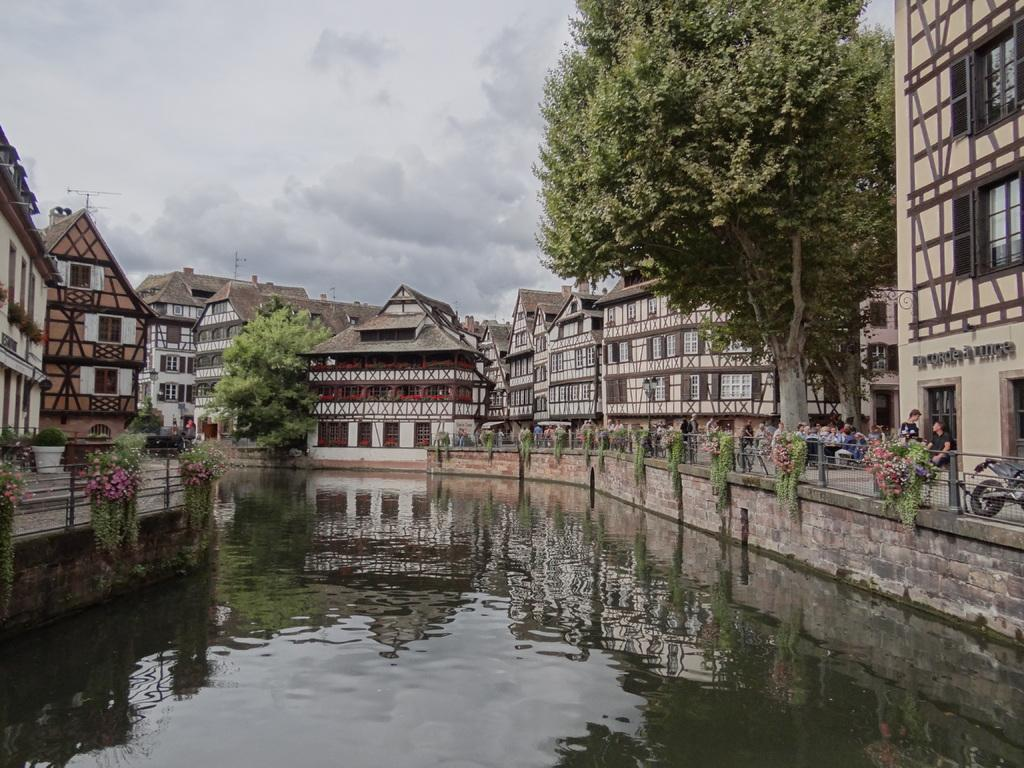What body of water is present in the image? There is a lake in the image. What surrounds the lake? There is a fence around the lake. What structures can be seen in the image? There are buildings visible in the image. What type of vegetation is present in the image? There are trees in the image. Are there any people in the image? Yes, there are people in the image. What type of powder can be seen covering the trees in the image? There is no powder present in the image, and the trees are not covered in any substance. 